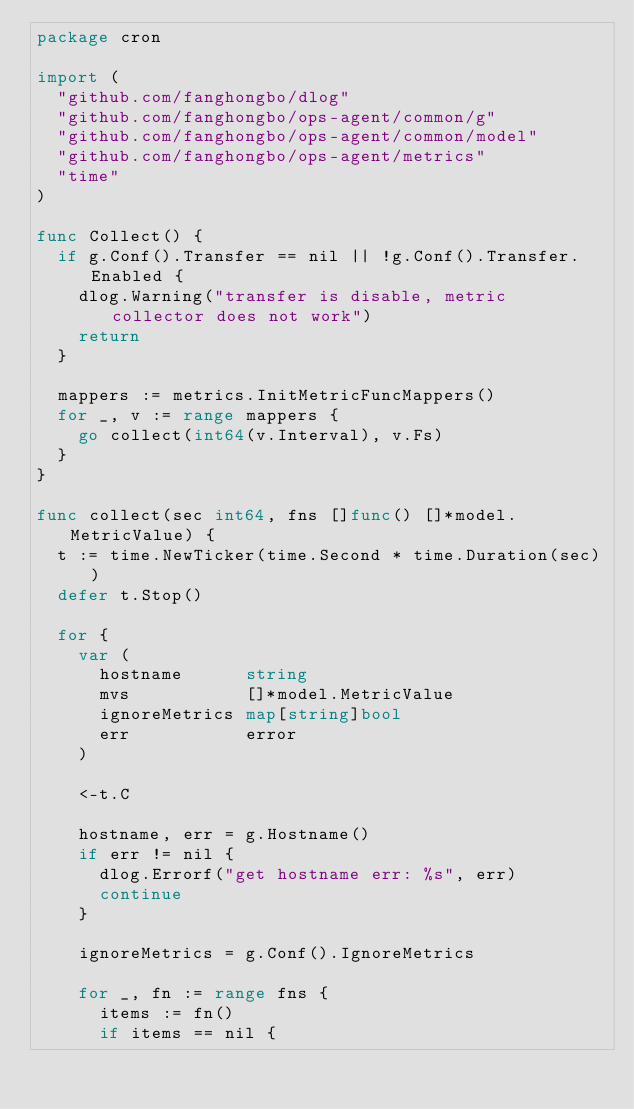<code> <loc_0><loc_0><loc_500><loc_500><_Go_>package cron

import (
	"github.com/fanghongbo/dlog"
	"github.com/fanghongbo/ops-agent/common/g"
	"github.com/fanghongbo/ops-agent/common/model"
	"github.com/fanghongbo/ops-agent/metrics"
	"time"
)

func Collect() {
	if g.Conf().Transfer == nil || !g.Conf().Transfer.Enabled {
		dlog.Warning("transfer is disable, metric collector does not work")
		return
	}

	mappers := metrics.InitMetricFuncMappers()
	for _, v := range mappers {
		go collect(int64(v.Interval), v.Fs)
	}
}

func collect(sec int64, fns []func() []*model.MetricValue) {
	t := time.NewTicker(time.Second * time.Duration(sec))
	defer t.Stop()

	for {
		var (
			hostname      string
			mvs           []*model.MetricValue
			ignoreMetrics map[string]bool
			err           error
		)

		<-t.C

		hostname, err = g.Hostname()
		if err != nil {
			dlog.Errorf("get hostname err: %s", err)
			continue
		}

		ignoreMetrics = g.Conf().IgnoreMetrics

		for _, fn := range fns {
			items := fn()
			if items == nil {</code> 